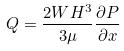Convert formula to latex. <formula><loc_0><loc_0><loc_500><loc_500>Q = \frac { 2 W H ^ { 3 } } { 3 \mu } \frac { \partial P } { \partial x }</formula> 